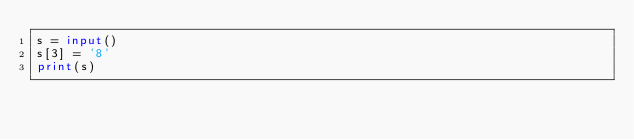Convert code to text. <code><loc_0><loc_0><loc_500><loc_500><_Python_>s = input()
s[3] = '8'
print(s)</code> 